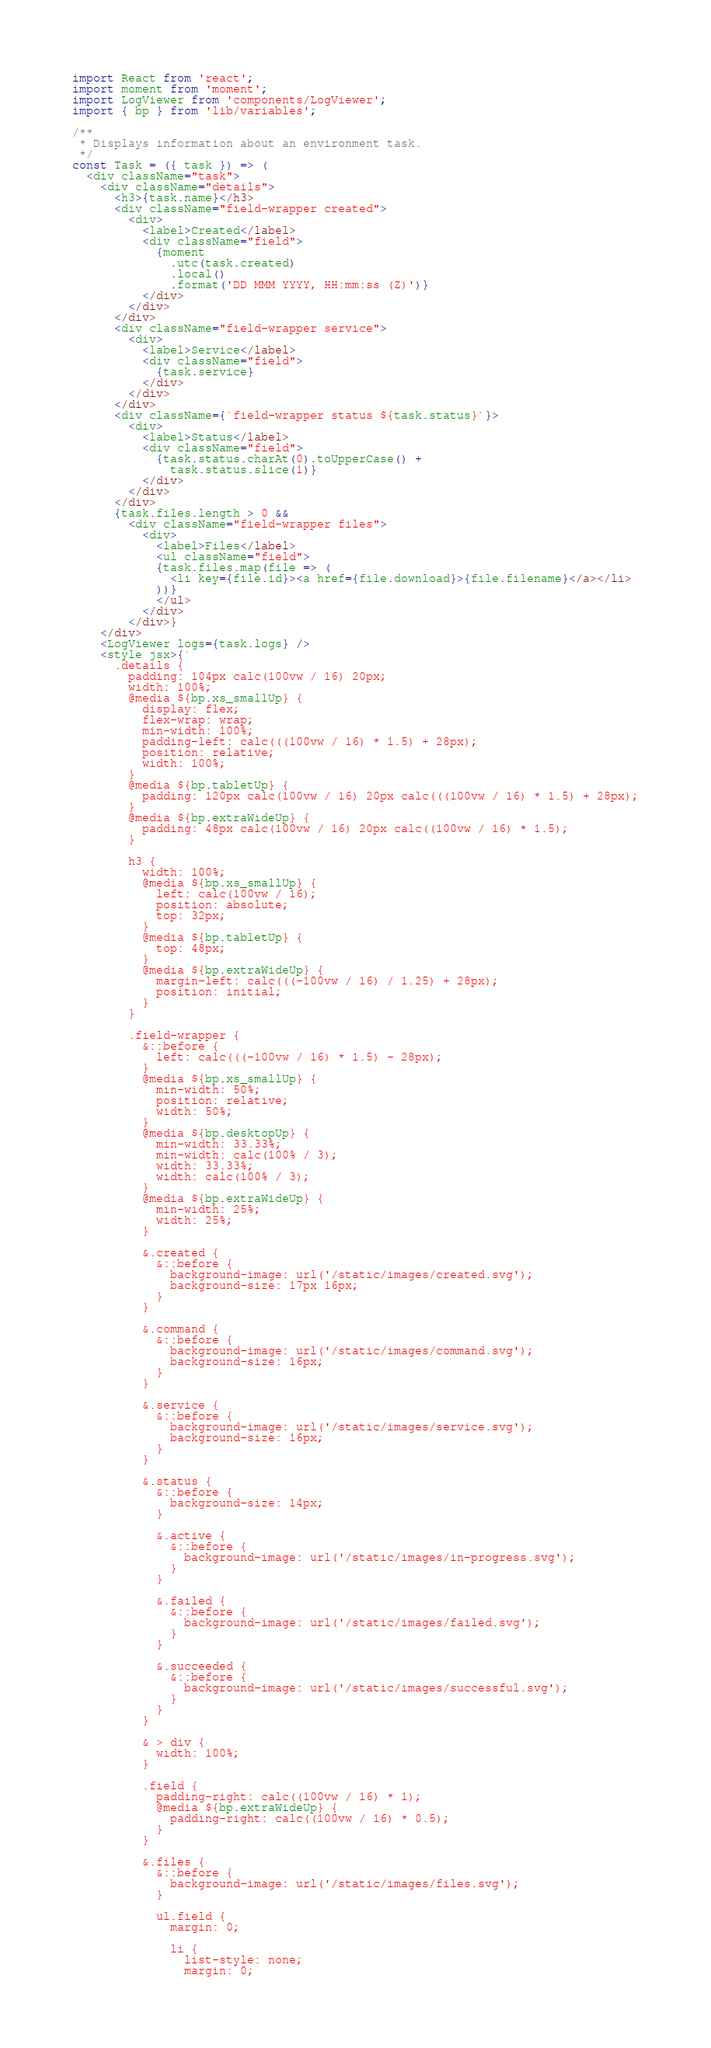Convert code to text. <code><loc_0><loc_0><loc_500><loc_500><_JavaScript_>import React from 'react';
import moment from 'moment';
import LogViewer from 'components/LogViewer';
import { bp } from 'lib/variables';

/**
 * Displays information about an environment task.
 */
const Task = ({ task }) => (
  <div className="task">
    <div className="details">
      <h3>{task.name}</h3>
      <div className="field-wrapper created">
        <div>
          <label>Created</label>
          <div className="field">
            {moment
              .utc(task.created)
              .local()
              .format('DD MMM YYYY, HH:mm:ss (Z)')}
          </div>
        </div>
      </div>
      <div className="field-wrapper service">
        <div>
          <label>Service</label>
          <div className="field">
            {task.service}
          </div>
        </div>
      </div>
      <div className={`field-wrapper status ${task.status}`}>
        <div>
          <label>Status</label>
          <div className="field">
            {task.status.charAt(0).toUpperCase() +
              task.status.slice(1)}
          </div>
        </div>
      </div>
      {task.files.length > 0 &&
        <div className="field-wrapper files">
          <div>
            <label>Files</label>
            <ul className="field">
            {task.files.map(file => (
              <li key={file.id}><a href={file.download}>{file.filename}</a></li>
            ))}
            </ul>
          </div>
        </div>}
    </div>
    <LogViewer logs={task.logs} />
    <style jsx>{`
      .details {
        padding: 104px calc(100vw / 16) 20px;
        width: 100%;
        @media ${bp.xs_smallUp} {
          display: flex;
          flex-wrap: wrap;
          min-width: 100%;
          padding-left: calc(((100vw / 16) * 1.5) + 28px);
          position: relative;
          width: 100%;
        }
        @media ${bp.tabletUp} {
          padding: 120px calc(100vw / 16) 20px calc(((100vw / 16) * 1.5) + 28px);
        }
        @media ${bp.extraWideUp} {
          padding: 48px calc(100vw / 16) 20px calc((100vw / 16) * 1.5);
        }

        h3 {
          width: 100%;
          @media ${bp.xs_smallUp} {
            left: calc(100vw / 16);
            position: absolute;
            top: 32px;
          }
          @media ${bp.tabletUp} {
            top: 48px;
          }
          @media ${bp.extraWideUp} {
            margin-left: calc(((-100vw / 16) / 1.25) + 28px);
            position: initial;
          }
        }

        .field-wrapper {
          &::before {
            left: calc(((-100vw / 16) * 1.5) - 28px);
          }
          @media ${bp.xs_smallUp} {
            min-width: 50%;
            position: relative;
            width: 50%;
          }
          @media ${bp.desktopUp} {
            min-width: 33.33%;
            min-width: calc(100% / 3);
            width: 33.33%;
            width: calc(100% / 3);
          }
          @media ${bp.extraWideUp} {
            min-width: 25%;
            width: 25%;
          }

          &.created {
            &::before {
              background-image: url('/static/images/created.svg');
              background-size: 17px 16px;
            }
          }

          &.command {
            &::before {
              background-image: url('/static/images/command.svg');
              background-size: 16px;
            }
          }

          &.service {
            &::before {
              background-image: url('/static/images/service.svg');
              background-size: 16px;
            }
          }

          &.status {
            &::before {
              background-size: 14px;
            }

            &.active {
              &::before {
                background-image: url('/static/images/in-progress.svg');
              }
            }

            &.failed {
              &::before {
                background-image: url('/static/images/failed.svg');
              }
            }

            &.succeeded {
              &::before {
                background-image: url('/static/images/successful.svg');
              }
            }
          }

          & > div {
            width: 100%;
          }

          .field {
            padding-right: calc((100vw / 16) * 1);
            @media ${bp.extraWideUp} {
              padding-right: calc((100vw / 16) * 0.5);
            }
          }

          &.files {
            &::before {
              background-image: url('/static/images/files.svg');
            }

            ul.field {
              margin: 0;

              li {
                list-style: none;
                margin: 0;</code> 